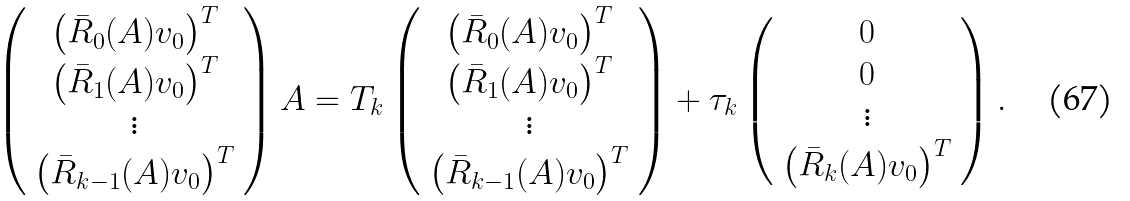Convert formula to latex. <formula><loc_0><loc_0><loc_500><loc_500>\left ( \begin{array} { c } \left ( \bar { R } _ { 0 } ( A ) v _ { 0 } \right ) ^ { T } \\ \left ( \bar { R } _ { 1 } ( A ) v _ { 0 } \right ) ^ { T } \\ \vdots \\ \left ( \bar { R } _ { k - 1 } ( A ) v _ { 0 } \right ) ^ { T } \\ \end{array} \right ) A = T _ { k } \left ( \begin{array} { c } \left ( \bar { R } _ { 0 } ( A ) v _ { 0 } \right ) ^ { T } \\ \left ( \bar { R } _ { 1 } ( A ) v _ { 0 } \right ) ^ { T } \\ \vdots \\ \left ( \bar { R } _ { k - 1 } ( A ) v _ { 0 } \right ) ^ { T } \\ \end{array} \right ) + \tau _ { k } \left ( \begin{array} { c } 0 \\ 0 \\ \vdots \\ \left ( \bar { R } _ { k } ( A ) v _ { 0 } \right ) ^ { T } \end{array} \right ) .</formula> 